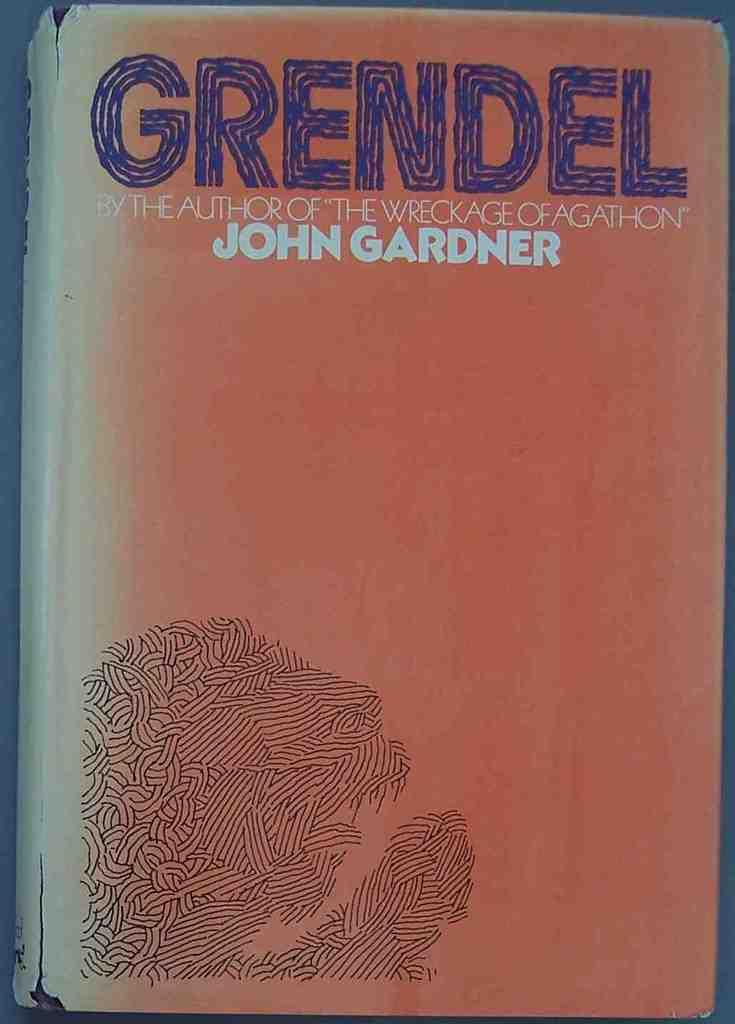Provide a one-sentence caption for the provided image. The bookcover for Grendel by the author of The Wreckage of Agathon, John Gardner is shown. 